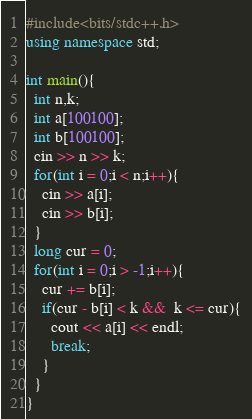<code> <loc_0><loc_0><loc_500><loc_500><_C++_>#include<bits/stdc++.h>
using namespace std;

int main(){
  int n,k;
  int a[100100];
  int b[100100];
  cin >> n >> k;
  for(int i = 0;i < n;i++){
    cin >> a[i];
    cin >> b[i];
  }
  long cur = 0;
  for(int i = 0;i > -1;i++){
    cur += b[i];
    if(cur - b[i] < k &&  k <= cur){
      cout << a[i] << endl;
      break;
    }
  }
}</code> 